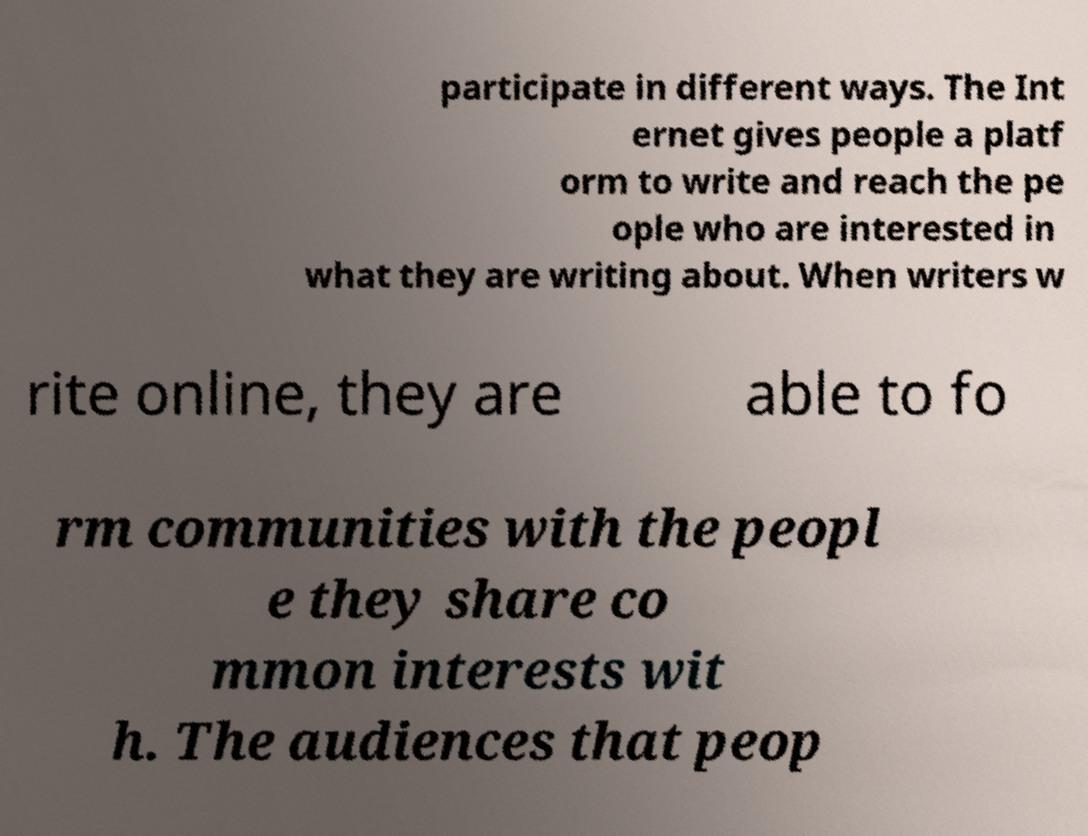Could you assist in decoding the text presented in this image and type it out clearly? participate in different ways. The Int ernet gives people a platf orm to write and reach the pe ople who are interested in what they are writing about. When writers w rite online, they are able to fo rm communities with the peopl e they share co mmon interests wit h. The audiences that peop 